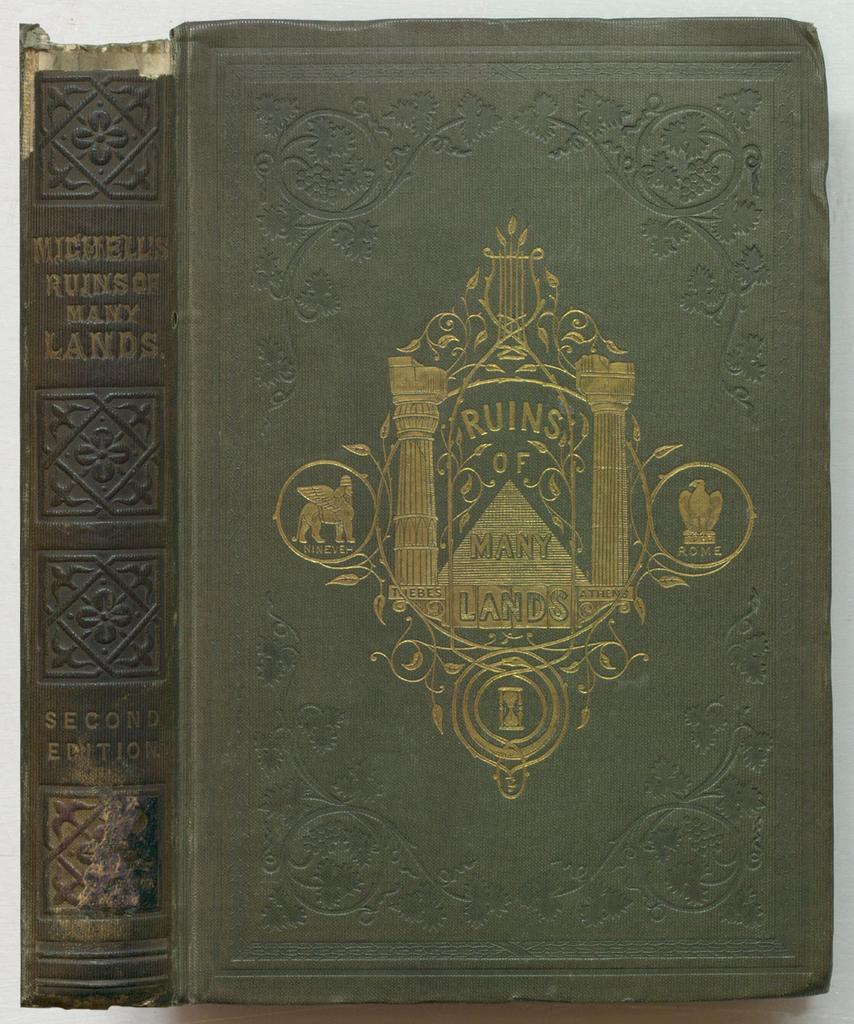Provide a one-sentence caption for the provided image. The cover and spine of an old book entitled "Ruins of Many Lands". 